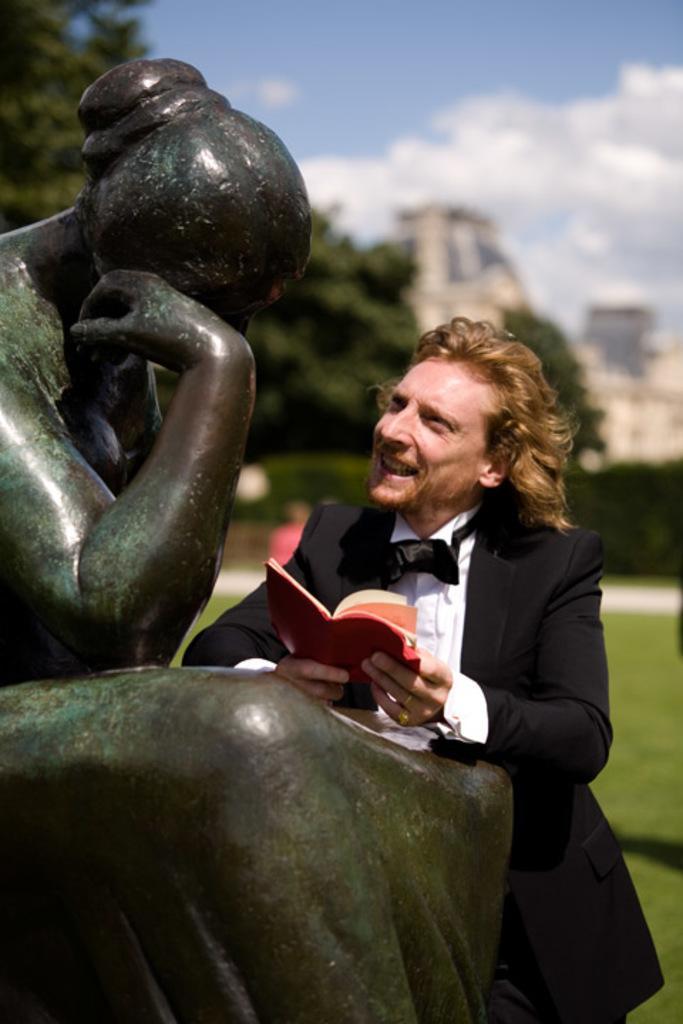Please provide a concise description of this image. Beside this statue a person is standing and holding a book. Background it is blur. We can see trees, grass and sky. Sky is cloudy. 